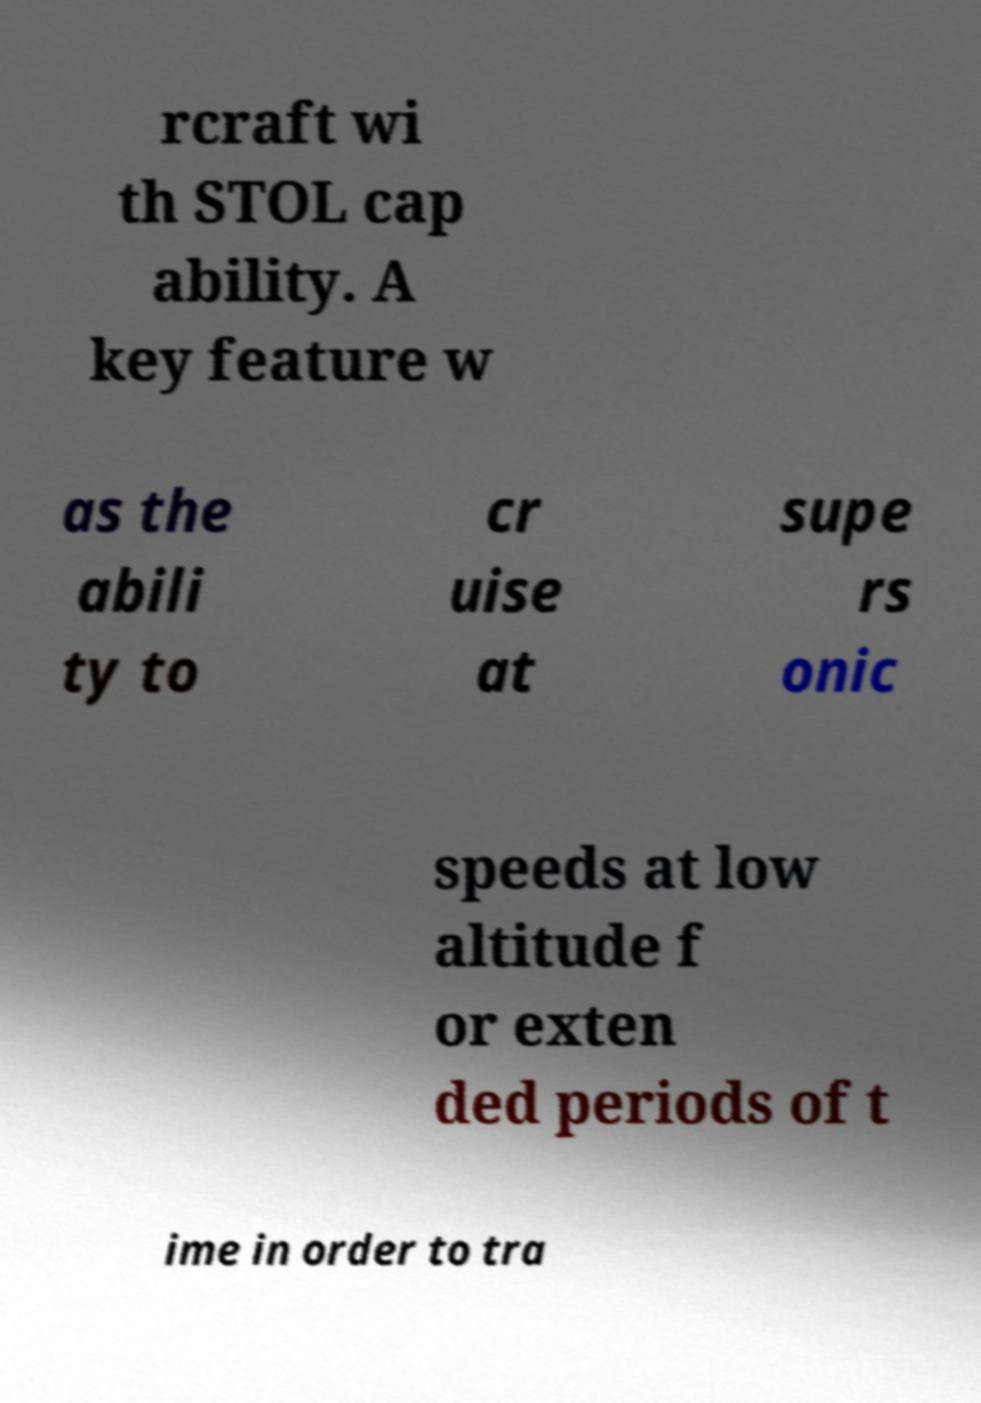Please read and relay the text visible in this image. What does it say? rcraft wi th STOL cap ability. A key feature w as the abili ty to cr uise at supe rs onic speeds at low altitude f or exten ded periods of t ime in order to tra 